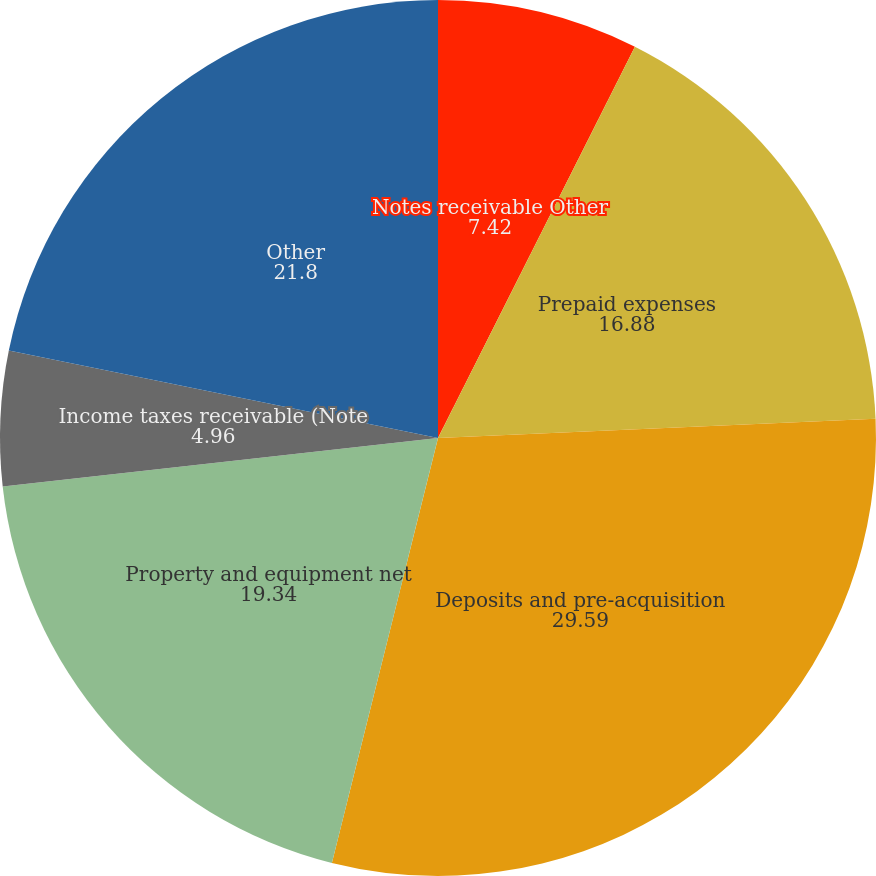Convert chart to OTSL. <chart><loc_0><loc_0><loc_500><loc_500><pie_chart><fcel>Notes receivable Other<fcel>Prepaid expenses<fcel>Deposits and pre-acquisition<fcel>Property and equipment net<fcel>Income taxes receivable (Note<fcel>Other<nl><fcel>7.42%<fcel>16.88%<fcel>29.59%<fcel>19.34%<fcel>4.96%<fcel>21.8%<nl></chart> 